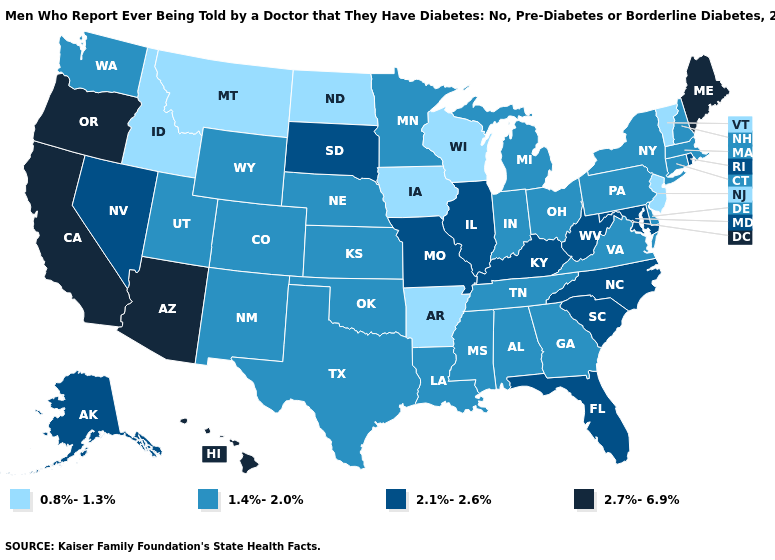Name the states that have a value in the range 2.1%-2.6%?
Quick response, please. Alaska, Florida, Illinois, Kentucky, Maryland, Missouri, Nevada, North Carolina, Rhode Island, South Carolina, South Dakota, West Virginia. What is the value of Maine?
Short answer required. 2.7%-6.9%. Does South Carolina have a higher value than Utah?
Be succinct. Yes. Among the states that border Virginia , does Maryland have the highest value?
Quick response, please. Yes. Does the first symbol in the legend represent the smallest category?
Answer briefly. Yes. How many symbols are there in the legend?
Concise answer only. 4. What is the highest value in states that border Mississippi?
Be succinct. 1.4%-2.0%. Among the states that border Maryland , which have the highest value?
Answer briefly. West Virginia. Which states have the highest value in the USA?
Concise answer only. Arizona, California, Hawaii, Maine, Oregon. What is the value of South Dakota?
Concise answer only. 2.1%-2.6%. Name the states that have a value in the range 2.7%-6.9%?
Give a very brief answer. Arizona, California, Hawaii, Maine, Oregon. Does Montana have the same value as North Dakota?
Give a very brief answer. Yes. Does Vermont have the lowest value in the USA?
Concise answer only. Yes. What is the highest value in the USA?
Be succinct. 2.7%-6.9%. Does South Carolina have the lowest value in the USA?
Keep it brief. No. 